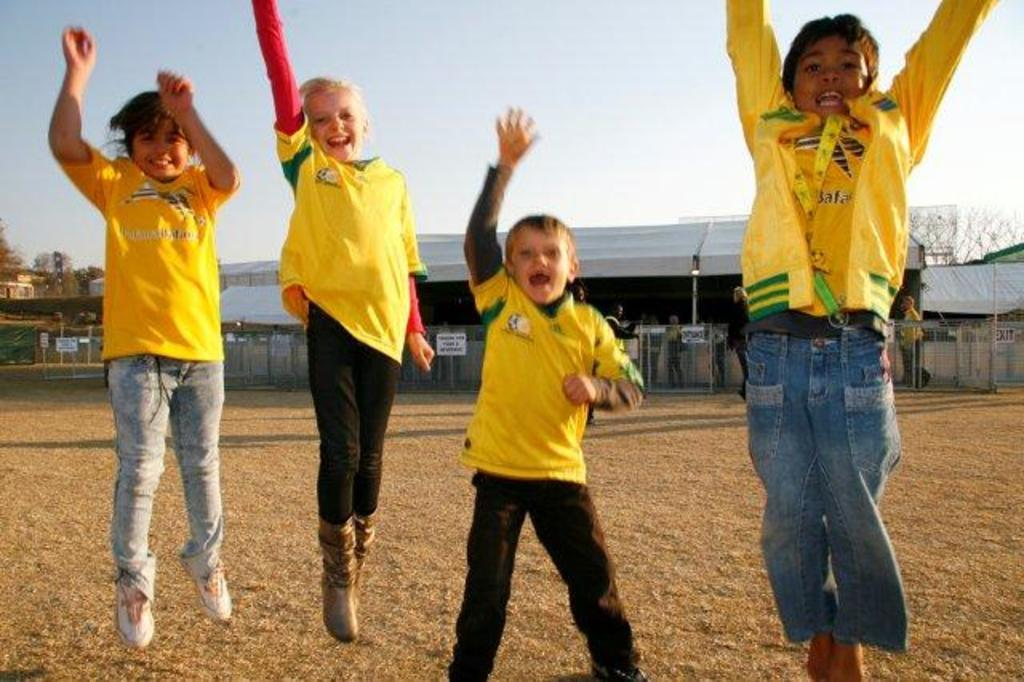How many children are in the image? There are four children in the image. What can be seen in the background of the image? In the background, there are railings, a shed, trees, and the sky. Are there any other people besides the children in the image? Yes, there are people in the image. What type of argument is taking place between the crows in the image? There are no crows present in the image, so no argument can be observed. 